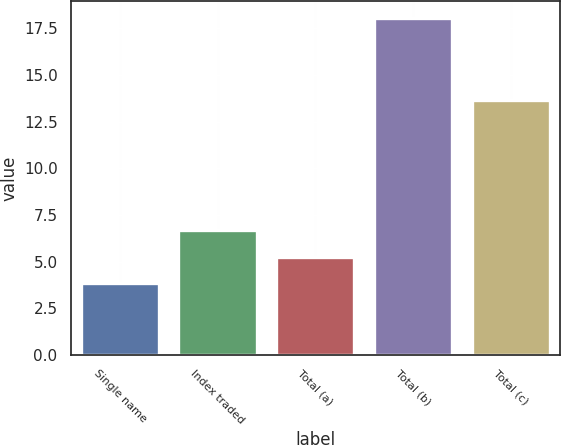Convert chart to OTSL. <chart><loc_0><loc_0><loc_500><loc_500><bar_chart><fcel>Single name<fcel>Index traded<fcel>Total (a)<fcel>Total (b)<fcel>Total (c)<nl><fcel>3.84<fcel>6.68<fcel>5.26<fcel>18.06<fcel>13.67<nl></chart> 